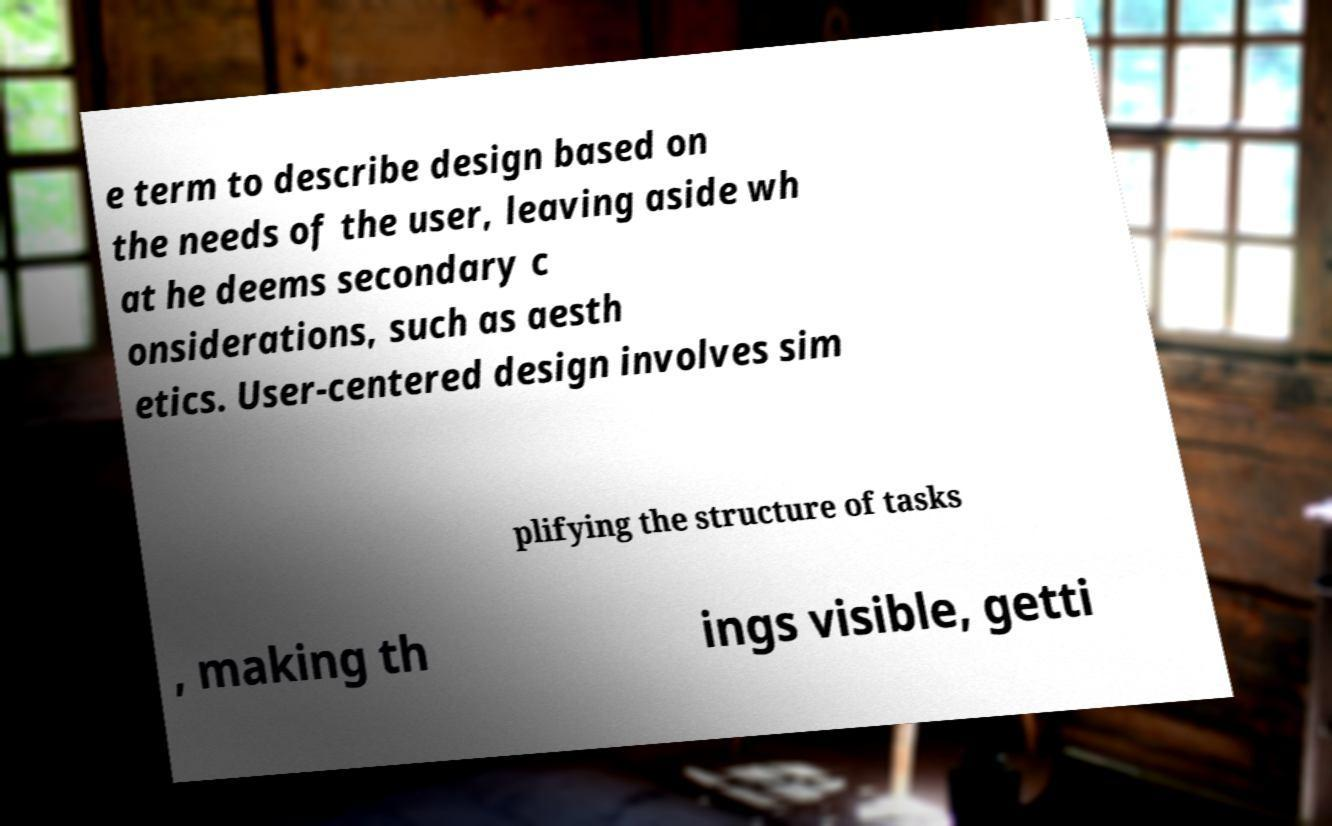There's text embedded in this image that I need extracted. Can you transcribe it verbatim? e term to describe design based on the needs of the user, leaving aside wh at he deems secondary c onsiderations, such as aesth etics. User-centered design involves sim plifying the structure of tasks , making th ings visible, getti 